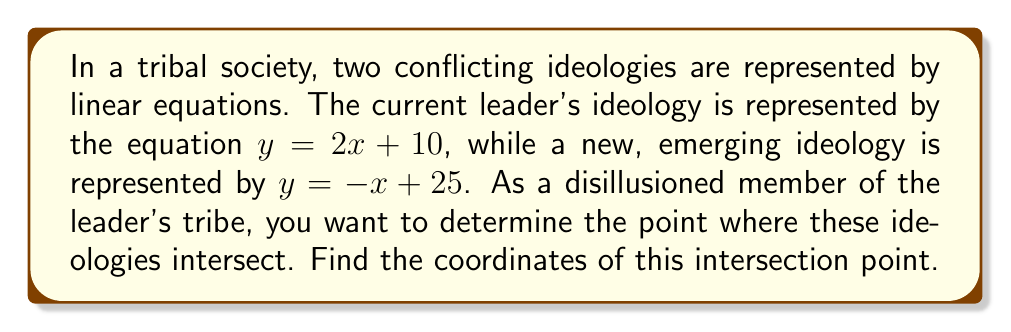Can you solve this math problem? To find the point of intersection between two linear equations, we need to solve them simultaneously:

1) Leader's ideology: $y = 2x + 10$
2) Emerging ideology: $y = -x + 25$

At the point of intersection, both equations are true. So, we can set them equal to each other:

$$2x + 10 = -x + 25$$

Now, let's solve for x:

$$2x + x = 25 - 10$$
$$3x = 15$$
$$x = 5$$

To find y, we can substitute x = 5 into either of the original equations. Let's use the leader's ideology equation:

$$y = 2(5) + 10$$
$$y = 10 + 10$$
$$y = 20$$

Therefore, the point of intersection is (5, 20).

This point represents where the two ideologies align, potentially indicating a critical juncture for change or compromise in the tribal society.
Answer: (5, 20) 